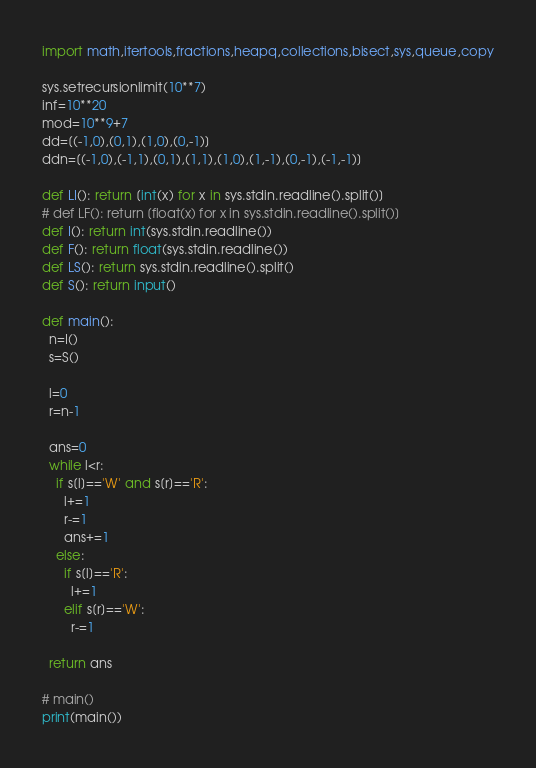<code> <loc_0><loc_0><loc_500><loc_500><_Python_>import math,itertools,fractions,heapq,collections,bisect,sys,queue,copy

sys.setrecursionlimit(10**7)
inf=10**20
mod=10**9+7
dd=[(-1,0),(0,1),(1,0),(0,-1)]
ddn=[(-1,0),(-1,1),(0,1),(1,1),(1,0),(1,-1),(0,-1),(-1,-1)]

def LI(): return [int(x) for x in sys.stdin.readline().split()]
# def LF(): return [float(x) for x in sys.stdin.readline().split()]
def I(): return int(sys.stdin.readline())
def F(): return float(sys.stdin.readline())
def LS(): return sys.stdin.readline().split()
def S(): return input()

def main():
  n=I()
  s=S()

  l=0
  r=n-1

  ans=0
  while l<r:
    if s[l]=='W' and s[r]=='R':
      l+=1
      r-=1
      ans+=1
    else:
      if s[l]=='R':
        l+=1
      elif s[r]=='W':
        r-=1

  return ans

# main()
print(main())
</code> 